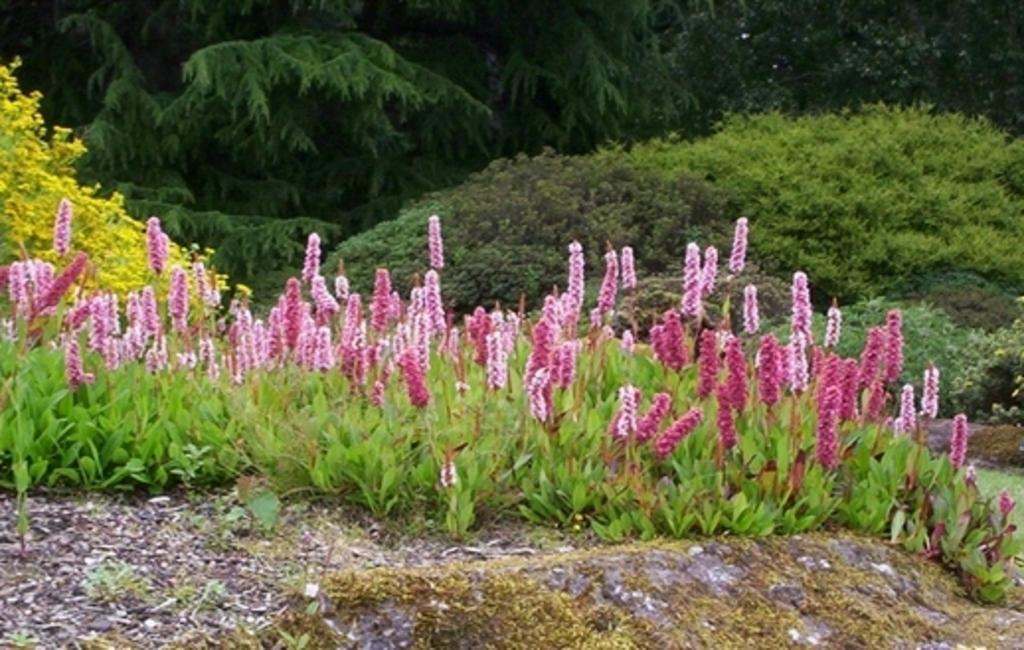How would you summarize this image in a sentence or two? In this image we can see flowers to the plants, bushes and trees. 